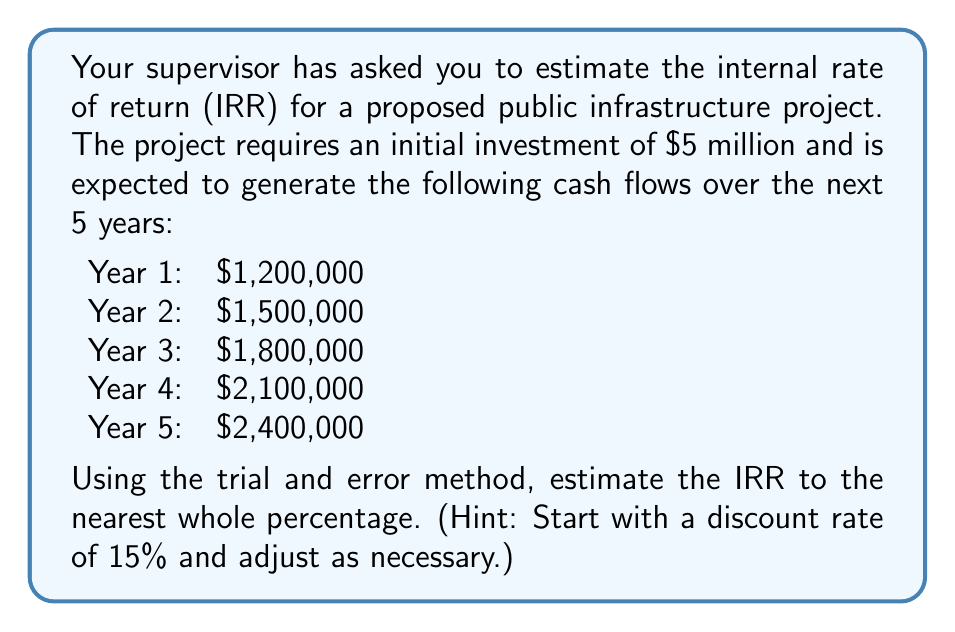Can you answer this question? To estimate the internal rate of return (IRR), we need to find the discount rate that makes the net present value (NPV) of the project equal to zero. We'll use the trial and error method, starting with a 15% discount rate.

The NPV formula is:

$$NPV = -C_0 + \sum_{t=1}^n \frac{C_t}{(1+r)^t}$$

Where:
$C_0$ is the initial investment
$C_t$ is the cash flow at time t
$r$ is the discount rate
$n$ is the number of periods

Let's calculate the NPV at 15%:

$$\begin{align*}
NPV &= -5,000,000 + \frac{1,200,000}{(1+0.15)^1} + \frac{1,500,000}{(1+0.15)^2} + \frac{1,800,000}{(1+0.15)^3} + \frac{2,100,000}{(1+0.15)^4} + \frac{2,400,000}{(1+0.15)^5} \\
&= -5,000,000 + 1,043,478 + 1,133,787 + 1,184,384 + 1,201,903 + 1,193,935 \\
&= 757,487
\end{align*}$$

The NPV is positive, so we need to try a higher discount rate. Let's try 20%:

$$\begin{align*}
NPV &= -5,000,000 + \frac{1,200,000}{(1+0.20)^1} + \frac{1,500,000}{(1+0.20)^2} + \frac{1,800,000}{(1+0.20)^3} + \frac{2,100,000}{(1+0.20)^4} + \frac{2,400,000}{(1+0.20)^5} \\
&= -5,000,000 + 1,000,000 + 1,041,667 + 1,041,667 + 1,012,731 + 965,530 \\
&= 61,595
\end{align*}$$

The NPV is still positive, but closer to zero. Let's try 21%:

$$\begin{align*}
NPV &= -5,000,000 + \frac{1,200,000}{(1+0.21)^1} + \frac{1,500,000}{(1+0.21)^2} + \frac{1,800,000}{(1+0.21)^3} + \frac{2,100,000}{(1+0.21)^4} + \frac{2,400,000}{(1+0.21)^5} \\
&= -5,000,000 + 991,736 + 1,024,590 + 1,018,072 + 980,442 + 927,135 \\
&= -58,025
\end{align*}$$

The NPV is now negative, which means the IRR is between 20% and 21%. Since we're asked to estimate to the nearest whole percentage, we can conclude that the IRR is approximately 21%.
Answer: The estimated internal rate of return (IRR) for the proposed public infrastructure project is 21%. 